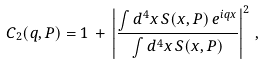<formula> <loc_0><loc_0><loc_500><loc_500>C _ { 2 } ( { q } , { P } ) = 1 \, + \, \left | \frac { \int d ^ { 4 } x \, S ( x , { P } ) \, e ^ { i q x } } { \int d ^ { 4 } x \, S ( x , { P } ) } \right | ^ { 2 } \, ,</formula> 